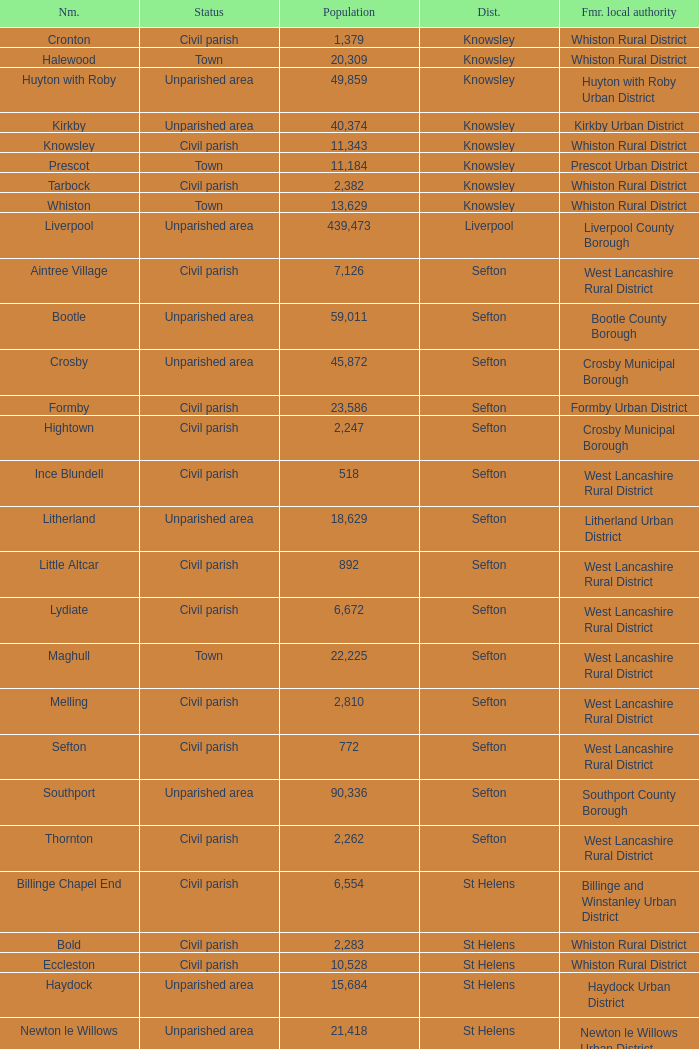What is the district of wallasey Wirral. 